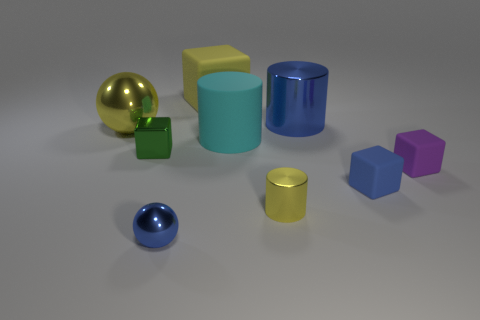Subtract all purple cylinders. Subtract all cyan cubes. How many cylinders are left? 3 Add 1 blue shiny spheres. How many objects exist? 10 Subtract all cubes. How many objects are left? 5 Subtract 1 blue balls. How many objects are left? 8 Subtract all tiny purple metal cylinders. Subtract all large blue cylinders. How many objects are left? 8 Add 1 large yellow matte things. How many large yellow matte things are left? 2 Add 8 cyan cylinders. How many cyan cylinders exist? 9 